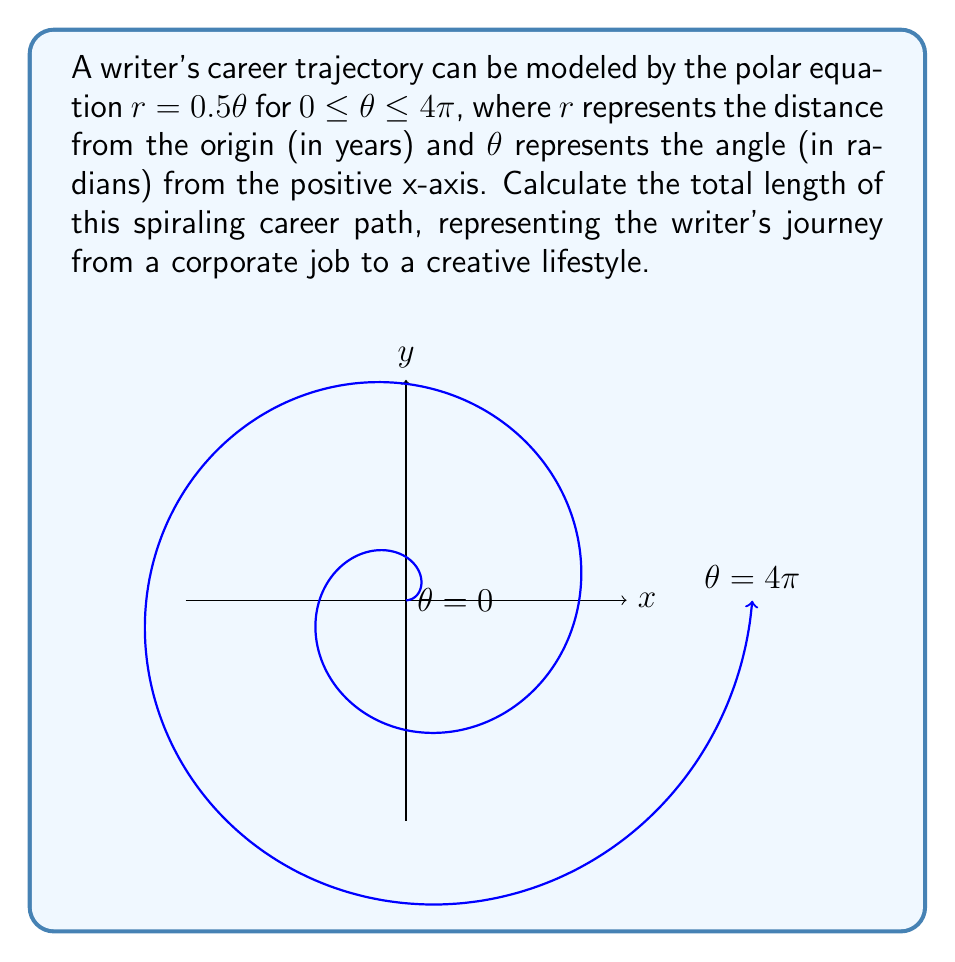Can you solve this math problem? To find the length of the spiraling career trajectory, we need to use the formula for arc length in polar coordinates:

$$L = \int_a^b \sqrt{r^2 + \left(\frac{dr}{d\theta}\right)^2} d\theta$$

Given:
- $r = 0.5\theta$
- $0 \leq \theta \leq 4\pi$

Steps:
1) First, we need to find $\frac{dr}{d\theta}$:
   $\frac{dr}{d\theta} = 0.5$

2) Now, let's substitute these into the arc length formula:
   $$L = \int_0^{4\pi} \sqrt{(0.5\theta)^2 + (0.5)^2} d\theta$$

3) Simplify under the square root:
   $$L = \int_0^{4\pi} \sqrt{0.25\theta^2 + 0.25} d\theta$$
   $$L = 0.5 \int_0^{4\pi} \sqrt{\theta^2 + 1} d\theta$$

4) This integral can be solved using the substitution $\theta = \sinh u$:
   $$L = 0.5 \int_0^{\sinh^{-1}(4\pi)} \sqrt{\sinh^2 u + 1} \cosh u du$$
   $$L = 0.5 \int_0^{\sinh^{-1}(4\pi)} \cosh^2 u du$$

5) Using the identity $\cosh^2 u = \frac{1}{2}(\cosh 2u + 1)$:
   $$L = 0.25 \int_0^{\sinh^{-1}(4\pi)} (\cosh 2u + 1) du$$
   $$L = 0.25 \left[\frac{1}{2}\sinh 2u + u\right]_0^{\sinh^{-1}(4\pi)}$$

6) Evaluate the integral:
   $$L = 0.25 \left[\frac{1}{2}\sinh(2\sinh^{-1}(4\pi)) + \sinh^{-1}(4\pi)\right]$$

7) Simplify using the identity $\sinh(2\sinh^{-1}x) = 2x\sqrt{1+x^2}$:
   $$L = 0.25 \left[4\pi\sqrt{1+(4\pi)^2} + \sinh^{-1}(4\pi)\right]$$

This represents the total length of the writer's spiraling career trajectory in years.
Answer: $L = 0.25 \left[4\pi\sqrt{1+(4\pi)^2} + \sinh^{-1}(4\pi)\right]$ years 